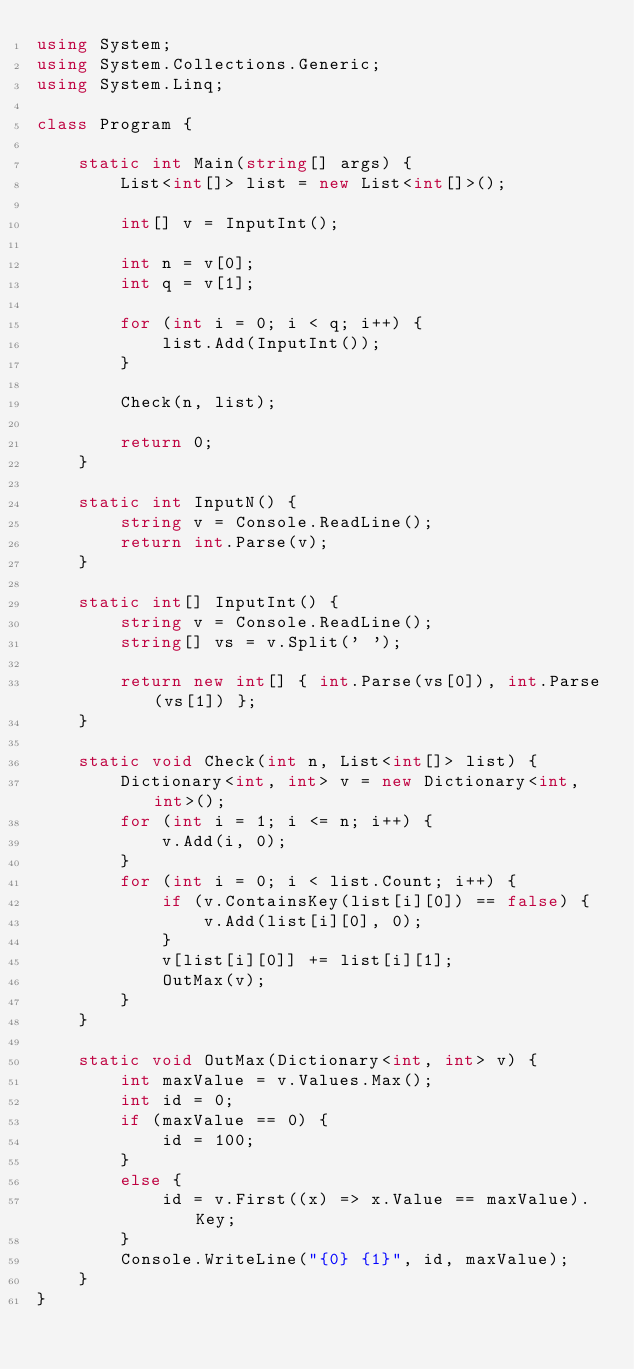Convert code to text. <code><loc_0><loc_0><loc_500><loc_500><_C#_>using System;
using System.Collections.Generic;
using System.Linq;

class Program {

    static int Main(string[] args) {
        List<int[]> list = new List<int[]>();

        int[] v = InputInt();

        int n = v[0];
        int q = v[1];

        for (int i = 0; i < q; i++) {
            list.Add(InputInt());
        }

        Check(n, list);

        return 0;
    }

    static int InputN() {
        string v = Console.ReadLine();
        return int.Parse(v);
    }

    static int[] InputInt() {
        string v = Console.ReadLine();
        string[] vs = v.Split(' ');

        return new int[] { int.Parse(vs[0]), int.Parse(vs[1]) };
    }

    static void Check(int n, List<int[]> list) {
        Dictionary<int, int> v = new Dictionary<int, int>();
        for (int i = 1; i <= n; i++) {
            v.Add(i, 0);
        }
        for (int i = 0; i < list.Count; i++) {
            if (v.ContainsKey(list[i][0]) == false) {
                v.Add(list[i][0], 0);
            }
            v[list[i][0]] += list[i][1];
            OutMax(v);
        }
    }

    static void OutMax(Dictionary<int, int> v) {
        int maxValue = v.Values.Max();
        int id = 0;
        if (maxValue == 0) {
            id = 100;
        }
        else {
            id = v.First((x) => x.Value == maxValue).Key;
        }
        Console.WriteLine("{0} {1}", id, maxValue);
    }
}</code> 